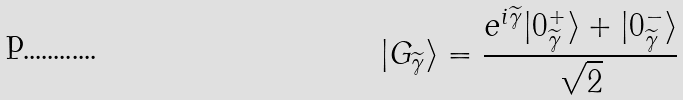<formula> <loc_0><loc_0><loc_500><loc_500>| G _ { \widetilde { \gamma } } \rangle = \frac { e ^ { i \widetilde { \gamma } } | 0 ^ { + } _ { \widetilde { \gamma } } \rangle + | 0 ^ { - } _ { \widetilde { \gamma } } \rangle } { \sqrt { 2 } }</formula> 